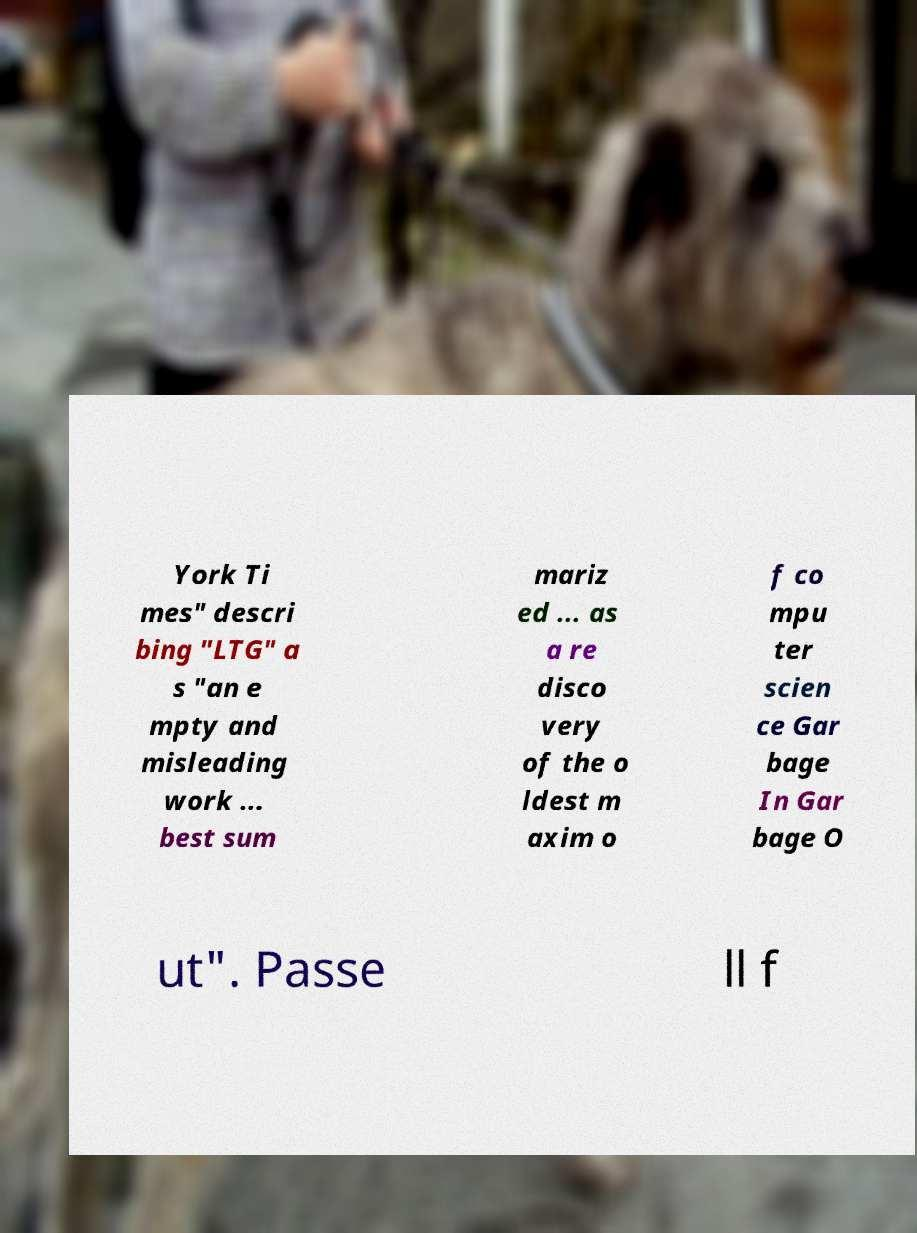Can you accurately transcribe the text from the provided image for me? York Ti mes" descri bing "LTG" a s "an e mpty and misleading work ... best sum mariz ed ... as a re disco very of the o ldest m axim o f co mpu ter scien ce Gar bage In Gar bage O ut". Passe ll f 